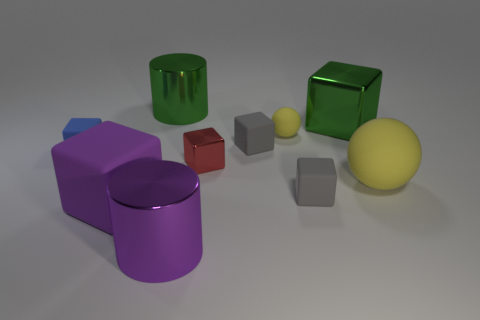There is a cylinder that is behind the metallic thing in front of the large yellow sphere; is there a big purple object that is in front of it?
Provide a succinct answer. Yes. There is a small gray object that is in front of the small red metal object that is in front of the green metal cube; what is it made of?
Give a very brief answer. Rubber. The big thing that is right of the tiny red cube and in front of the green shiny cube is made of what material?
Your response must be concise. Rubber. Are there any big yellow objects of the same shape as the small yellow object?
Your response must be concise. Yes. Is there a thing in front of the large cylinder that is left of the large purple metal cylinder?
Your response must be concise. Yes. What number of small blue objects have the same material as the green cylinder?
Offer a terse response. 0. Are there any large cyan shiny cubes?
Ensure brevity in your answer.  No. How many shiny cylinders have the same color as the big metallic block?
Your response must be concise. 1. Is the material of the small yellow thing the same as the cylinder in front of the blue object?
Offer a very short reply. No. Is the number of tiny yellow rubber things behind the big purple block greater than the number of big yellow shiny balls?
Offer a terse response. Yes. 